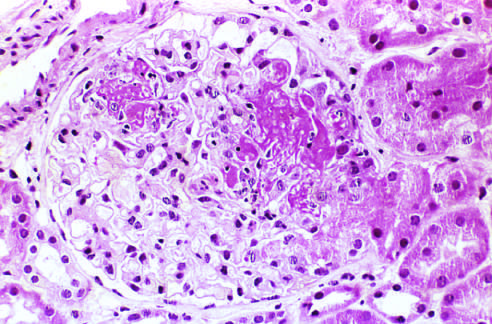s atrophy of the brain not prominent in this case?
Answer the question using a single word or phrase. No 